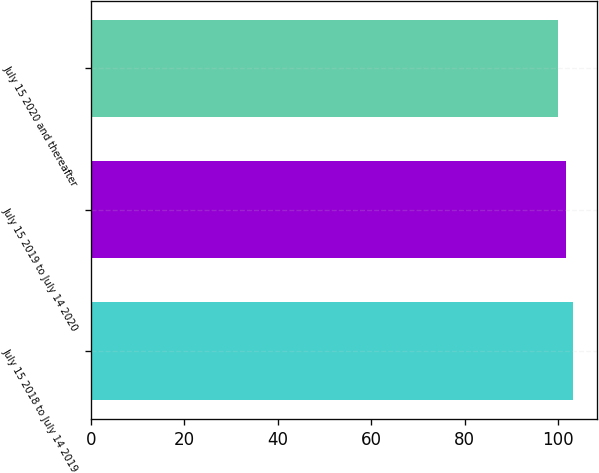<chart> <loc_0><loc_0><loc_500><loc_500><bar_chart><fcel>July 15 2018 to July 14 2019<fcel>July 15 2019 to July 14 2020<fcel>July 15 2020 and thereafter<nl><fcel>103.12<fcel>101.56<fcel>100<nl></chart> 